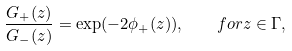Convert formula to latex. <formula><loc_0><loc_0><loc_500><loc_500>\frac { G _ { + } ( z ) } { G _ { - } ( z ) } = \exp ( - 2 \phi _ { + } ( z ) ) , \quad f o r z \in \Gamma ,</formula> 